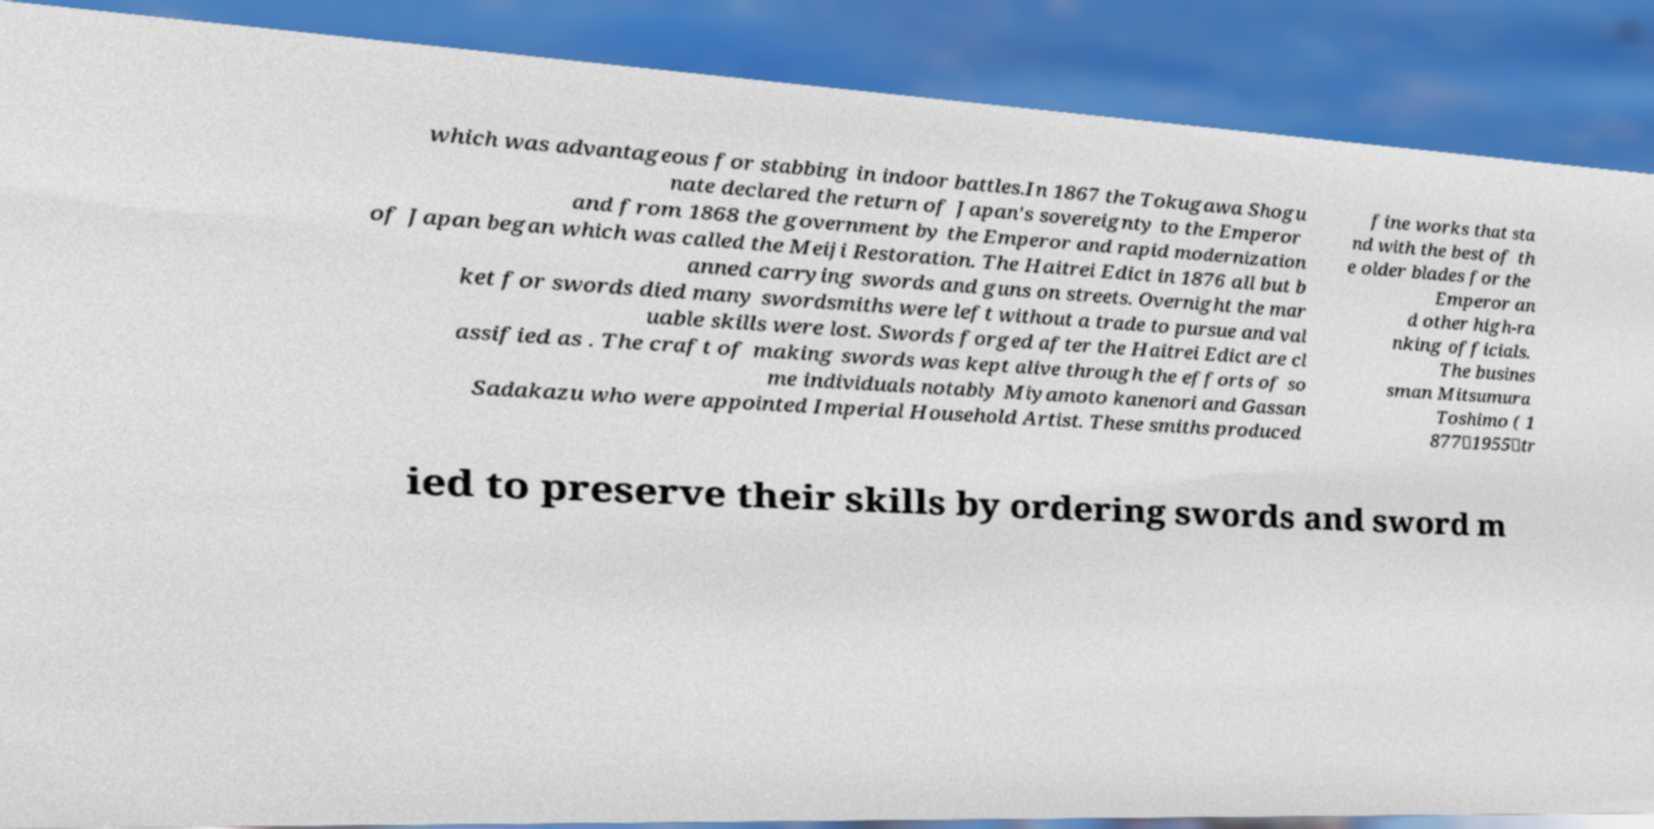Could you assist in decoding the text presented in this image and type it out clearly? which was advantageous for stabbing in indoor battles.In 1867 the Tokugawa Shogu nate declared the return of Japan's sovereignty to the Emperor and from 1868 the government by the Emperor and rapid modernization of Japan began which was called the Meiji Restoration. The Haitrei Edict in 1876 all but b anned carrying swords and guns on streets. Overnight the mar ket for swords died many swordsmiths were left without a trade to pursue and val uable skills were lost. Swords forged after the Haitrei Edict are cl assified as . The craft of making swords was kept alive through the efforts of so me individuals notably Miyamoto kanenori and Gassan Sadakazu who were appointed Imperial Household Artist. These smiths produced fine works that sta nd with the best of th e older blades for the Emperor an d other high-ra nking officials. The busines sman Mitsumura Toshimo ( 1 877－1955）tr ied to preserve their skills by ordering swords and sword m 